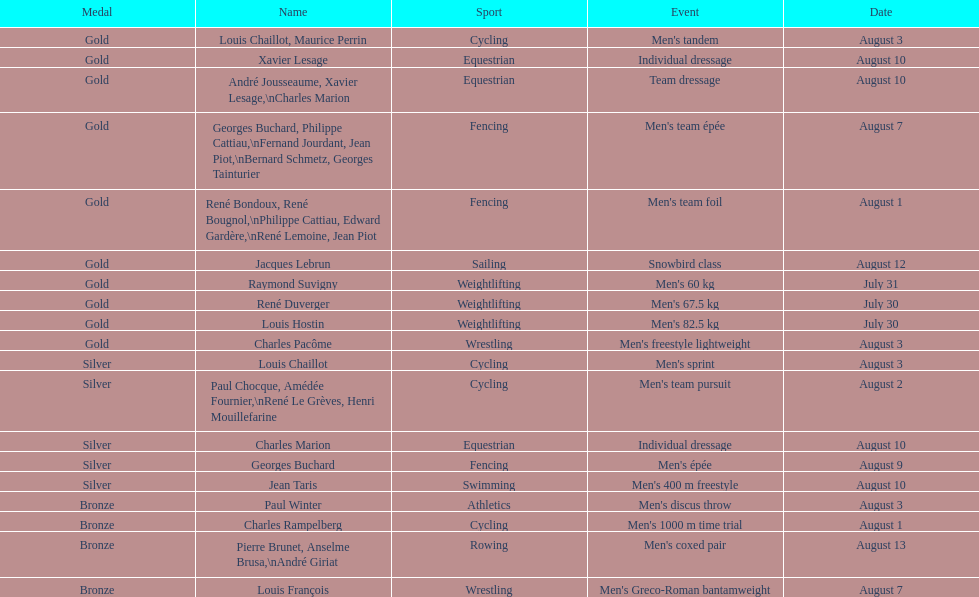What sport did louis challiot win the same medal as paul chocque in? Cycling. Could you parse the entire table? {'header': ['Medal', 'Name', 'Sport', 'Event', 'Date'], 'rows': [['Gold', 'Louis Chaillot, Maurice Perrin', 'Cycling', "Men's tandem", 'August 3'], ['Gold', 'Xavier Lesage', 'Equestrian', 'Individual dressage', 'August 10'], ['Gold', 'André Jousseaume, Xavier Lesage,\\nCharles Marion', 'Equestrian', 'Team dressage', 'August 10'], ['Gold', 'Georges Buchard, Philippe Cattiau,\\nFernand Jourdant, Jean Piot,\\nBernard Schmetz, Georges Tainturier', 'Fencing', "Men's team épée", 'August 7'], ['Gold', 'René Bondoux, René Bougnol,\\nPhilippe Cattiau, Edward Gardère,\\nRené Lemoine, Jean Piot', 'Fencing', "Men's team foil", 'August 1'], ['Gold', 'Jacques Lebrun', 'Sailing', 'Snowbird class', 'August 12'], ['Gold', 'Raymond Suvigny', 'Weightlifting', "Men's 60 kg", 'July 31'], ['Gold', 'René Duverger', 'Weightlifting', "Men's 67.5 kg", 'July 30'], ['Gold', 'Louis Hostin', 'Weightlifting', "Men's 82.5 kg", 'July 30'], ['Gold', 'Charles Pacôme', 'Wrestling', "Men's freestyle lightweight", 'August 3'], ['Silver', 'Louis Chaillot', 'Cycling', "Men's sprint", 'August 3'], ['Silver', 'Paul Chocque, Amédée Fournier,\\nRené Le Grèves, Henri Mouillefarine', 'Cycling', "Men's team pursuit", 'August 2'], ['Silver', 'Charles Marion', 'Equestrian', 'Individual dressage', 'August 10'], ['Silver', 'Georges Buchard', 'Fencing', "Men's épée", 'August 9'], ['Silver', 'Jean Taris', 'Swimming', "Men's 400 m freestyle", 'August 10'], ['Bronze', 'Paul Winter', 'Athletics', "Men's discus throw", 'August 3'], ['Bronze', 'Charles Rampelberg', 'Cycling', "Men's 1000 m time trial", 'August 1'], ['Bronze', 'Pierre Brunet, Anselme Brusa,\\nAndré Giriat', 'Rowing', "Men's coxed pair", 'August 13'], ['Bronze', 'Louis François', 'Wrestling', "Men's Greco-Roman bantamweight", 'August 7']]} 